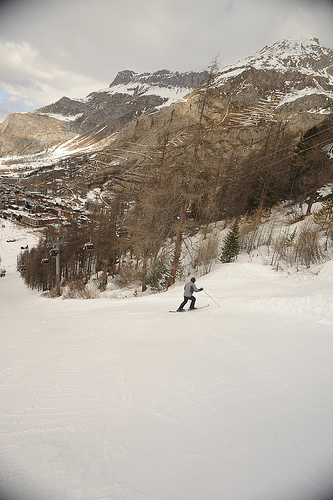How many ski lift chairs are visible? After carefully examining the image, it appears that there are no ski lift chairs visible in the frame. Instead, a skier can be seen enjoying a descent on the slopes, with a beautiful backdrop of mountainous terrain. 